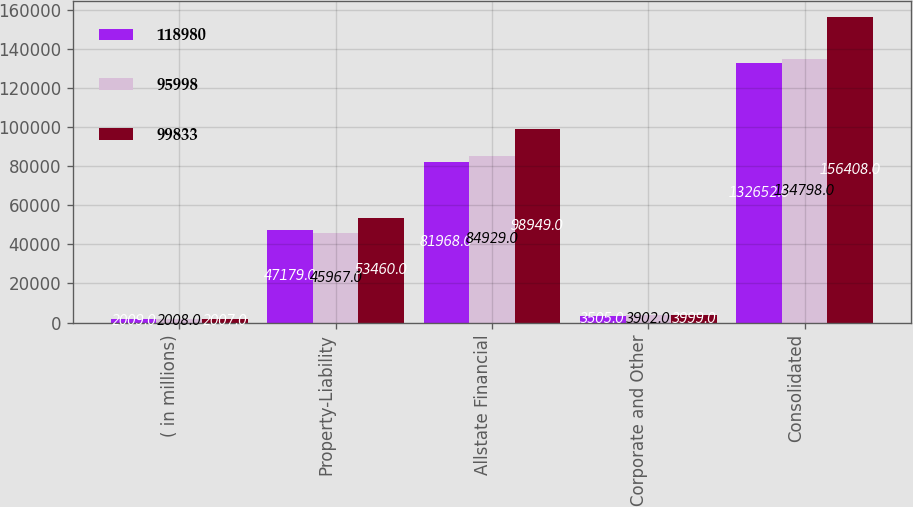Convert chart to OTSL. <chart><loc_0><loc_0><loc_500><loc_500><stacked_bar_chart><ecel><fcel>( in millions)<fcel>Property-Liability<fcel>Allstate Financial<fcel>Corporate and Other<fcel>Consolidated<nl><fcel>118980<fcel>2009<fcel>47179<fcel>81968<fcel>3505<fcel>132652<nl><fcel>95998<fcel>2008<fcel>45967<fcel>84929<fcel>3902<fcel>134798<nl><fcel>99833<fcel>2007<fcel>53460<fcel>98949<fcel>3999<fcel>156408<nl></chart> 